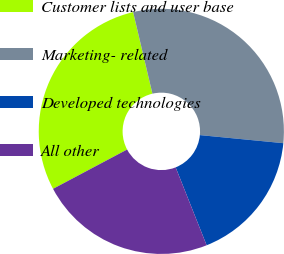Convert chart. <chart><loc_0><loc_0><loc_500><loc_500><pie_chart><fcel>Customer lists and user base<fcel>Marketing- related<fcel>Developed technologies<fcel>All other<nl><fcel>29.07%<fcel>30.23%<fcel>17.44%<fcel>23.26%<nl></chart> 